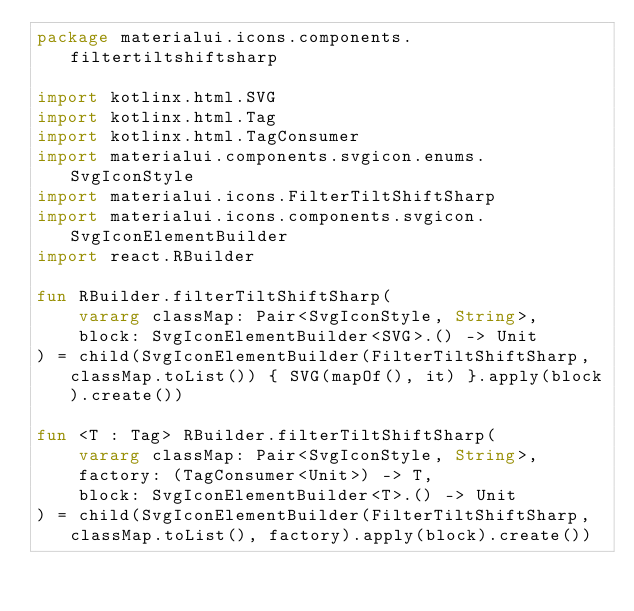<code> <loc_0><loc_0><loc_500><loc_500><_Kotlin_>package materialui.icons.components.filtertiltshiftsharp

import kotlinx.html.SVG
import kotlinx.html.Tag
import kotlinx.html.TagConsumer
import materialui.components.svgicon.enums.SvgIconStyle
import materialui.icons.FilterTiltShiftSharp
import materialui.icons.components.svgicon.SvgIconElementBuilder
import react.RBuilder

fun RBuilder.filterTiltShiftSharp(
    vararg classMap: Pair<SvgIconStyle, String>,
    block: SvgIconElementBuilder<SVG>.() -> Unit
) = child(SvgIconElementBuilder(FilterTiltShiftSharp, classMap.toList()) { SVG(mapOf(), it) }.apply(block).create())

fun <T : Tag> RBuilder.filterTiltShiftSharp(
    vararg classMap: Pair<SvgIconStyle, String>,
    factory: (TagConsumer<Unit>) -> T,
    block: SvgIconElementBuilder<T>.() -> Unit
) = child(SvgIconElementBuilder(FilterTiltShiftSharp, classMap.toList(), factory).apply(block).create())
</code> 